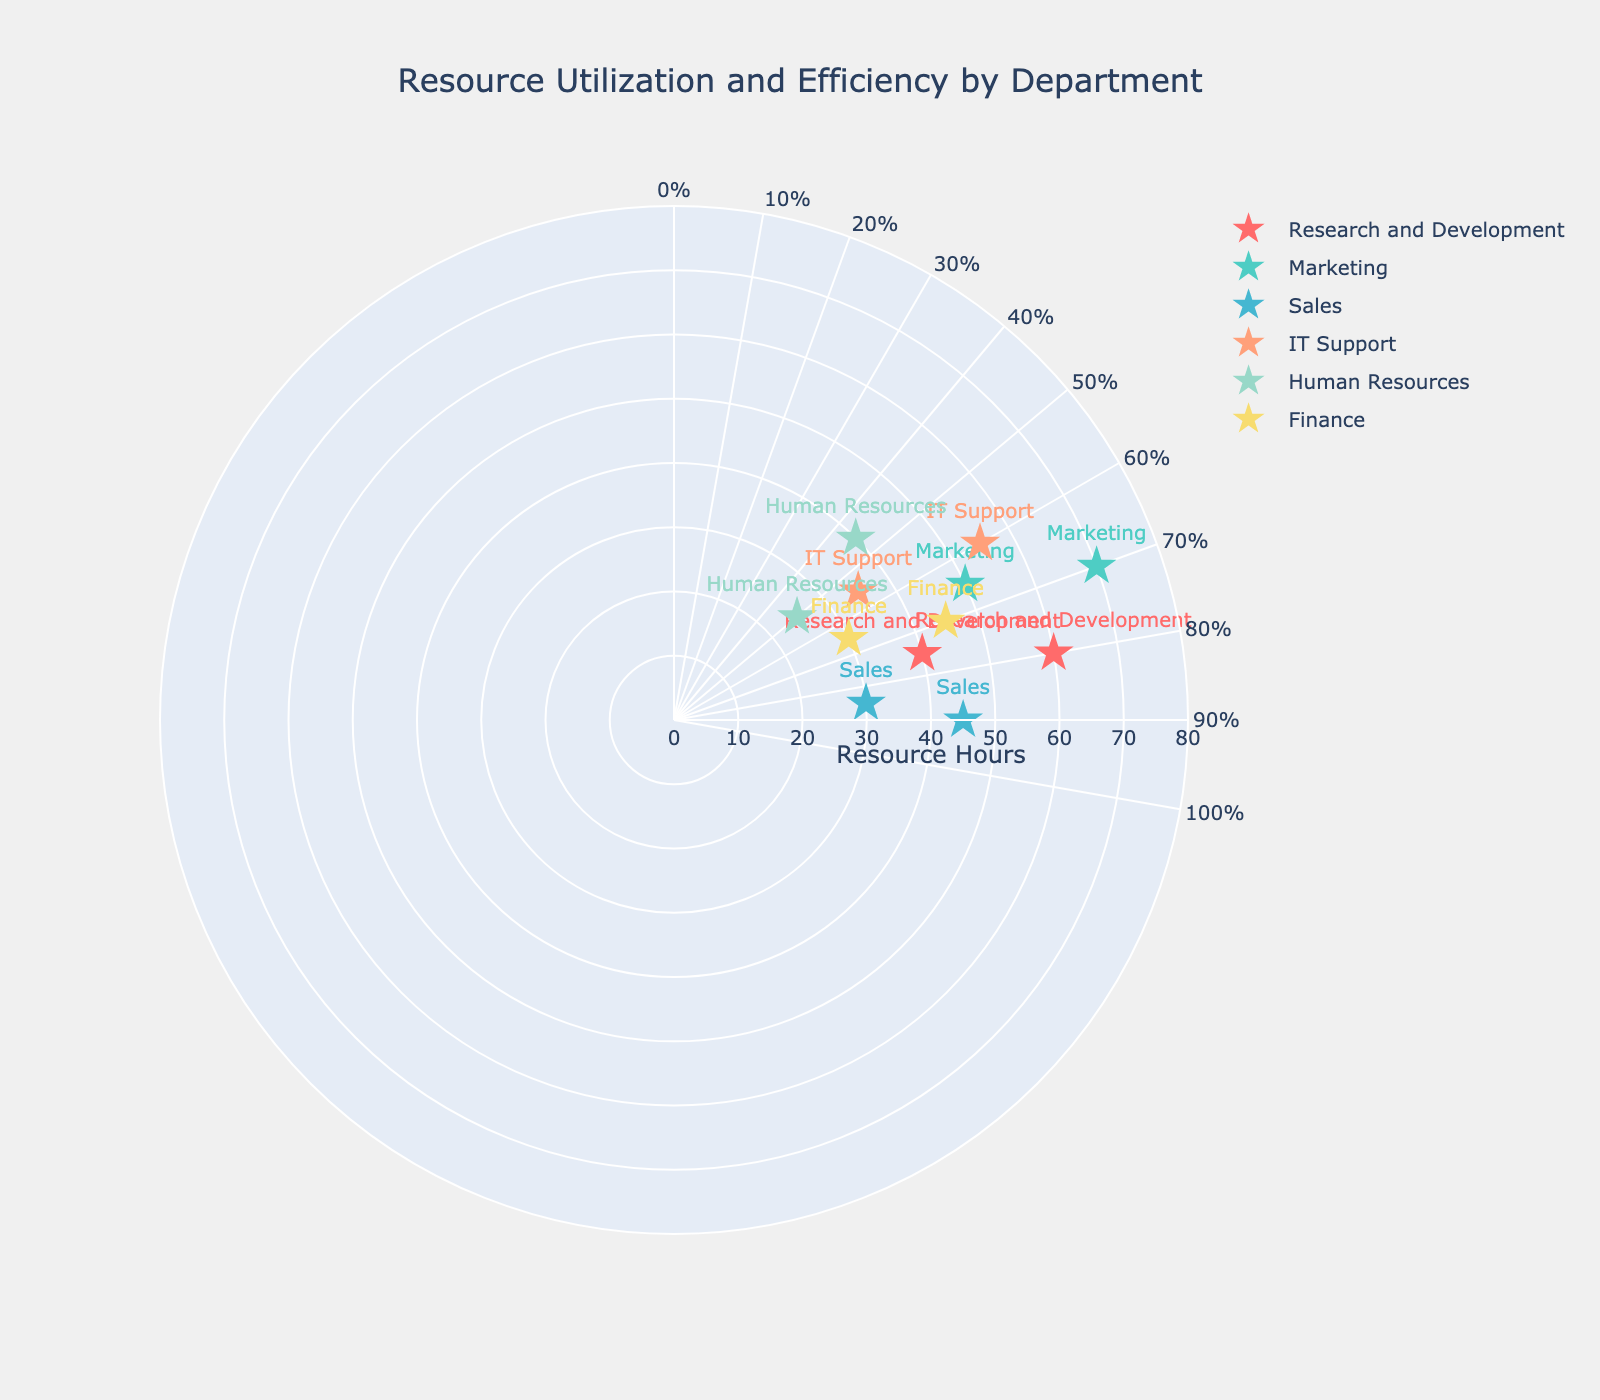what is the title of the polar scatter chart? The title is usually displayed at the top of the chart, providing an overview of what the figure represents. The title here reads "Resource Utilization and Efficiency by Department".
Answer: Resource Utilization and Efficiency by Department Which department has the highest efficiency for the given resource hours? To determine the highest efficiency, look for the data points with the furthest theta value (clockwise angle) within each department. 'Sales' department shows the highest efficiency of 90% with 45 resource hours.
Answer: Sales How many data points are plotted for each department? Each department has certain markers on the plot. By counting the data points for each, we identify that each department has two data points.
Answer: 2 what is the angular axis range in the polar scatter chart? The angular axis in polar charts usually represents a circular percentage scale. Observing the ticks, it ranges from 0% to 100%.
Answer: 0% to 100% Which department has the lowest efficiency value? The lowest efficiency value can be determined by the smallest theta value on the chart. 'Human Resources' has the lowest efficiency at 45%.
Answer: Human Resources Compare the resource hours for Research and Development and IT Support at their higher efficiency data points. Which department uses more resource hours? Find the higher efficiency point for both departments and compare their radial distances. Research and Development at 80% efficiency uses 60 hours, while IT Support at 60% efficiency uses 55 hours. Therefore, Research and Development uses more resource hours.
Answer: Research and Development What's the average efficiency of Finance department based on the plotted data points? For compositional questions: sum up the efficiencies for Finance (70% + 65%) and divide by the number of data points (2). (70 + 65) / 2 = 67.5%.
Answer: 67.5% Which department's data points display the greatest variation in resource hours for their given efficiencies? Calculate the difference between the highest and lowest resource hours within each department. The largest variation in hours is observed for the Marketing department with a range from 50 to 70, equating to a 20-hour difference.
Answer: Marketing What is the range of resource hours observed across all departments? The radial axis demonstrates the range of resource hours. To find the overall range, consider the smallest (25 hours for Human Resources) and largest (70 hours for Marketing) values from the chart, resulting in a 45-hour range.
Answer: 25 to 70 hours 